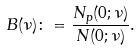<formula> <loc_0><loc_0><loc_500><loc_500>B ( \nu ) \colon = \frac { N _ { p } ( 0 ; \nu ) } { N ( 0 ; \nu ) } .</formula> 